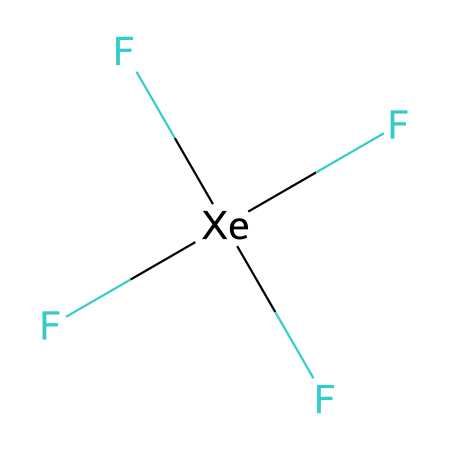What is the central atom of xenon tetrafluoride? In the SMILES representation, 'F[Xe](F)(F)F' shows 'Xe' as the central atom, which is denoted by its position and is surrounded by fluorine atoms.
Answer: xenon How many fluorine atoms are bonded to xenon in this compound? The notation '(F)(F)(F)F' indicates four fluorine atoms are directly connected to the xenon atom, as each 'F' represents a bond to fluorine.
Answer: 4 What type of hybridization is present in xenon tetrafluoride? Given that xenon is bonded to four fluorine atoms, it uses sp³d hybridization to accommodate five regions of electron density, including one lone pair of electrons.
Answer: sp³d Is xenon tetrafluoride polar or nonpolar? Although the individual Xe-F bonds are polar due to the electronegativity difference between xenon and fluorine, the symmetrical arrangement (square planar) of the molecule results in overall nonpolarity.
Answer: nonpolar What is the molecular geometry of xenon tetrafluoride? The arrangement of bonds and lone pairs around the central xenon leads to a square planar shape, which is characteristic of molecules with four bonds and two lone pairs.
Answer: square planar How does the presence of a noble gas affect the reactivity of xenon tetrafluoride? Noble gases like xenon have filled electron shells, which typically makes them less reactive; however, the formation of hypervalent compounds like XeF4 shows that xenon can engage in chemical bonding despite this general inertness.
Answer: less reactive 